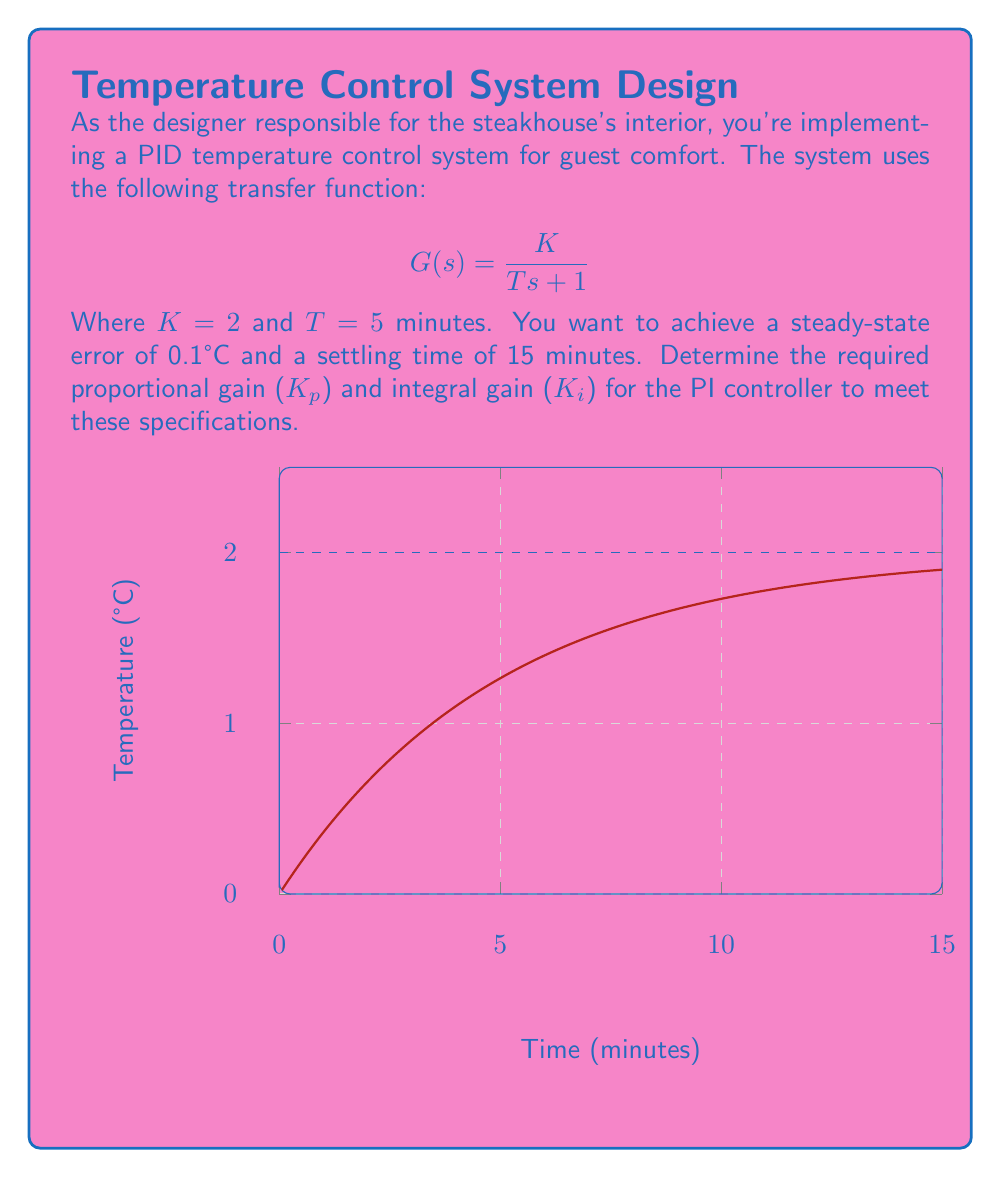Solve this math problem. Let's approach this step-by-step:

1) For a PI controller, the closed-loop transfer function is:

   $$T(s) = \frac{K_p K s + K_i K}{Ts^2 + (1+K_p K)s + K_i K}$$

2) The steady-state error for a step input is given by:

   $$e_{ss} = \frac{1}{1 + K_p K} = 0.1$$

3) Solving for $K_p$:

   $$K_p = \frac{1-0.1}{0.1K} = \frac{0.9}{0.2} = 4.5$$

4) The characteristic equation of the closed-loop system is:

   $$Ts^2 + (1+K_p K)s + K_i K = 0$$

5) For a second-order system, the settling time is approximately $4/\zeta\omega_n$, where $\zeta$ is the damping ratio and $\omega_n$ is the natural frequency. We want this to be 15 minutes:

   $$\frac{4}{\zeta\omega_n} = 15$$

6) Comparing the characteristic equation to the standard form $s^2 + 2\zeta\omega_n s + \omega_n^2 = 0$, we can equate:

   $$2\zeta\omega_n = \frac{1+K_p K}{T} = \frac{1+4.5*2}{5} = 1.9$$
   $$\omega_n^2 = \frac{K_i K}{T} = \frac{2K_i}{5}$$

7) Using the settling time equation:

   $$\frac{4}{15} = \zeta\omega_n = \frac{1.9}{2} = 0.95$$

8) Now we can solve for $K_i$:

   $$\omega_n = \frac{0.95}{\zeta} = \frac{0.95}{0.95/1.9} = 1.9$$
   $$\omega_n^2 = 3.61 = \frac{2K_i}{5}$$
   $$K_i = \frac{3.61 * 5}{2} = 9.025$$

Therefore, the required gains are $K_p = 4.5$ and $K_i = 9.025$.
Answer: $K_p = 4.5$, $K_i = 9.025$ 